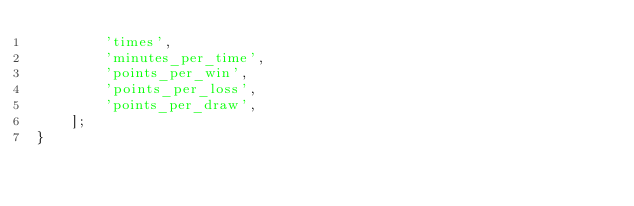Convert code to text. <code><loc_0><loc_0><loc_500><loc_500><_PHP_>        'times',
        'minutes_per_time',
        'points_per_win',
        'points_per_loss',
        'points_per_draw',
    ];
}
</code> 